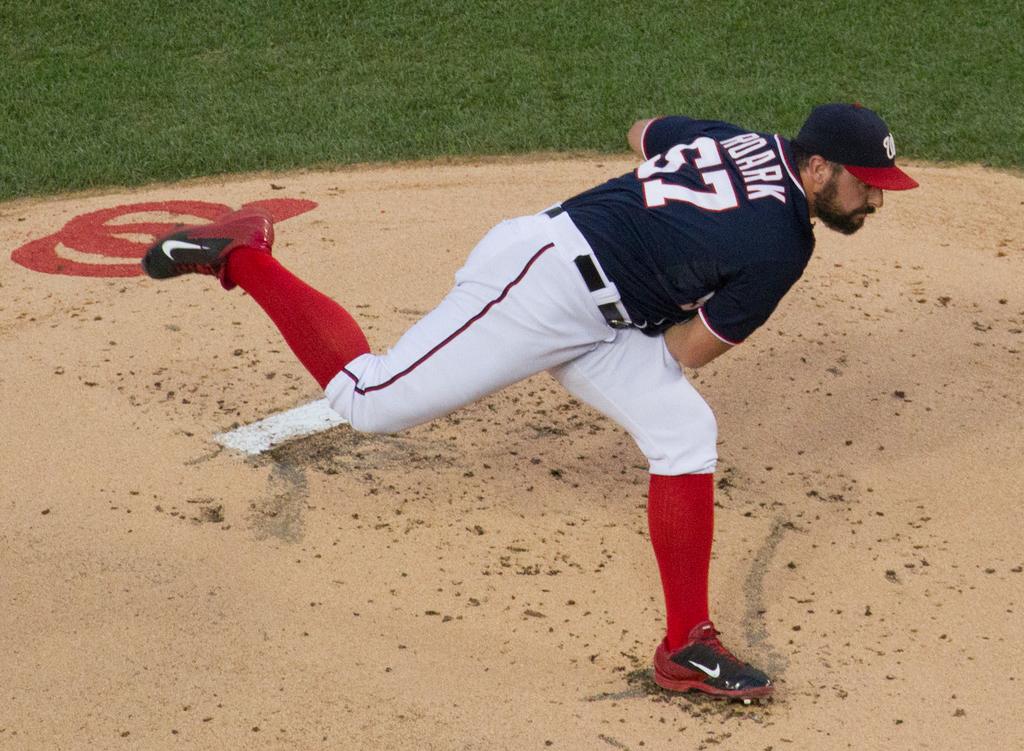What is player 57's last name?
Ensure brevity in your answer.  Roark. 